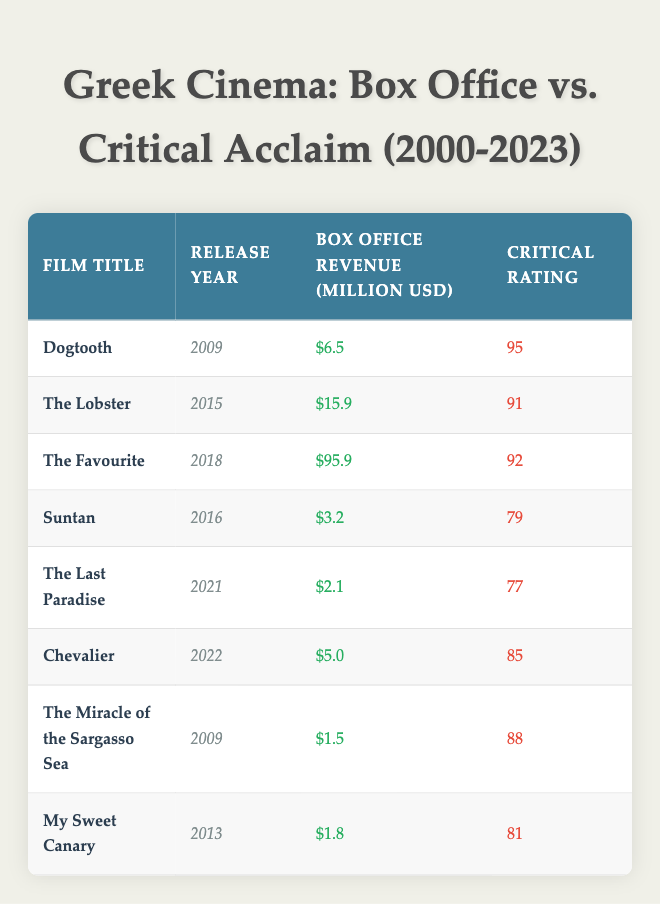What is the box office revenue of "The Favourite"? The revenue for "The Favourite" is stated in the table under the column "Box Office Revenue (Million USD)", which shows a value of 95.9.
Answer: 95.9 Which film has the highest critical rating? The critical ratings are listed in the "Critical Rating" column. By comparing the values, "Dogtooth" has the highest rating at 95.
Answer: Dogtooth What is the average box office revenue of the films released after 2015? The films released after 2015 are "The Favourite", "Chevalier", and "The Last Paradise". Their revenues are 95.9, 5.0, and 2.1 respectively. Adding these together gives 95.9 + 5.0 + 2.1 = 103.0, and dividing by the number of films (3) gives an average of 103.0 / 3 = 34.33.
Answer: 34.33 Did "Suntan" earn more than "Chevalier"? "Suntan" has a box office revenue of 3.2 while "Chevalier" has a revenue of 5.0, which means "Chevalier" earned more than "Suntan". Thus, the statement is false.
Answer: No What is the difference in critical ratings between the highest-rated and the lowest-rated films? The highest rating is for "Dogtooth" at 95 and the lowest rating is for "The Last Paradise" at 77. To find the difference, we subtract the lowest rating from the highest: 95 - 77 = 18.
Answer: 18 Which film released in 2021 has the lowest box office revenue? The film released in 2021 is "The Last Paradise" with a box office revenue of 2.1 million. There are no other films released in that year listed in the table, confirming that it has the lowest revenue.
Answer: The Last Paradise Is there a correlation between higher box office revenue and critical rating among the films listed? By observing the box office revenues and corresponding critical ratings, "The Favourite" has the highest revenue and solid critical rating but this does not apply to all films as "The Last Paradise" has a low revenue with a relatively low critical rating. This suggests no definitive correlation can be established without a clear pattern.
Answer: No What is the total box office revenue for all films released in 2009? The films released in 2009 are "Dogtooth" and "The Miracle of the Sargasso Sea." Their revenues of 6.5 and 1.5 million respectively sum to 6.5 + 1.5 = 8.0 million.
Answer: 8.0 How many films have a critical rating above 80? The films with ratings above 80 are "Dogtooth" (95), "The Lobster" (91), "The Favourite" (92), "Chevalier" (85), and "The Miracle of the Sargasso Sea" (88). This counts to a total of 5 films.
Answer: 5 